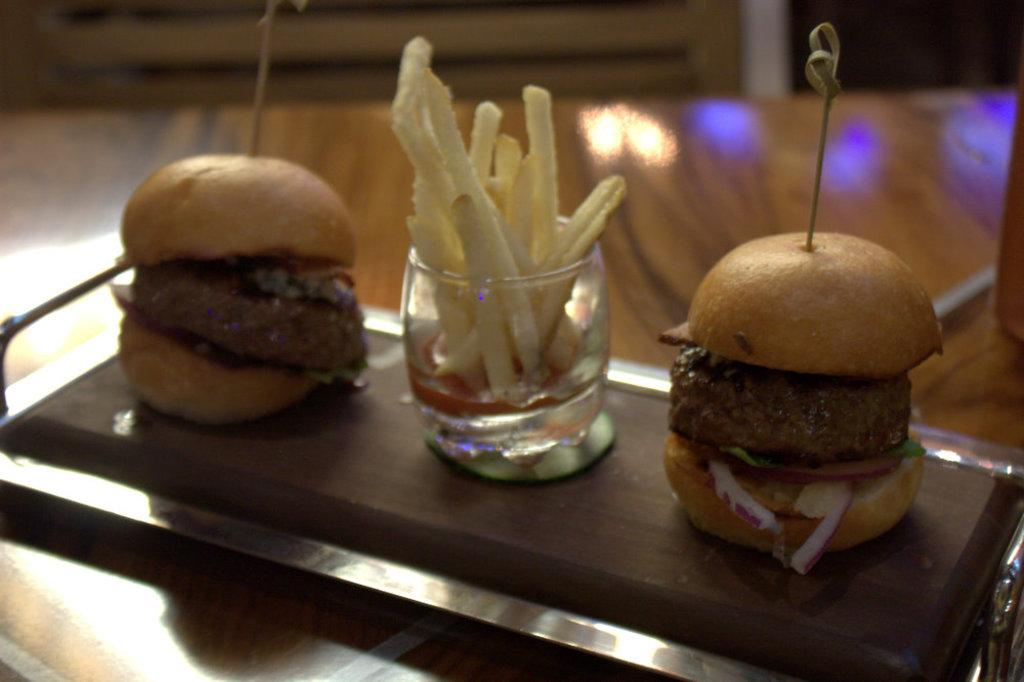What is the main subject of the image? The main subject of the image is a tray with food items in the center. Can you describe the food items in the tray? Unfortunately, the facts provided do not give specific details about the food items in the tray. What else is visible in the image besides the tray? There is a glass with french fries in it. What time of day is depicted in the image? The facts provided do not give any information about the time of day. What type of grape is being served in the image? There is no mention of grapes in the image or the provided facts. 